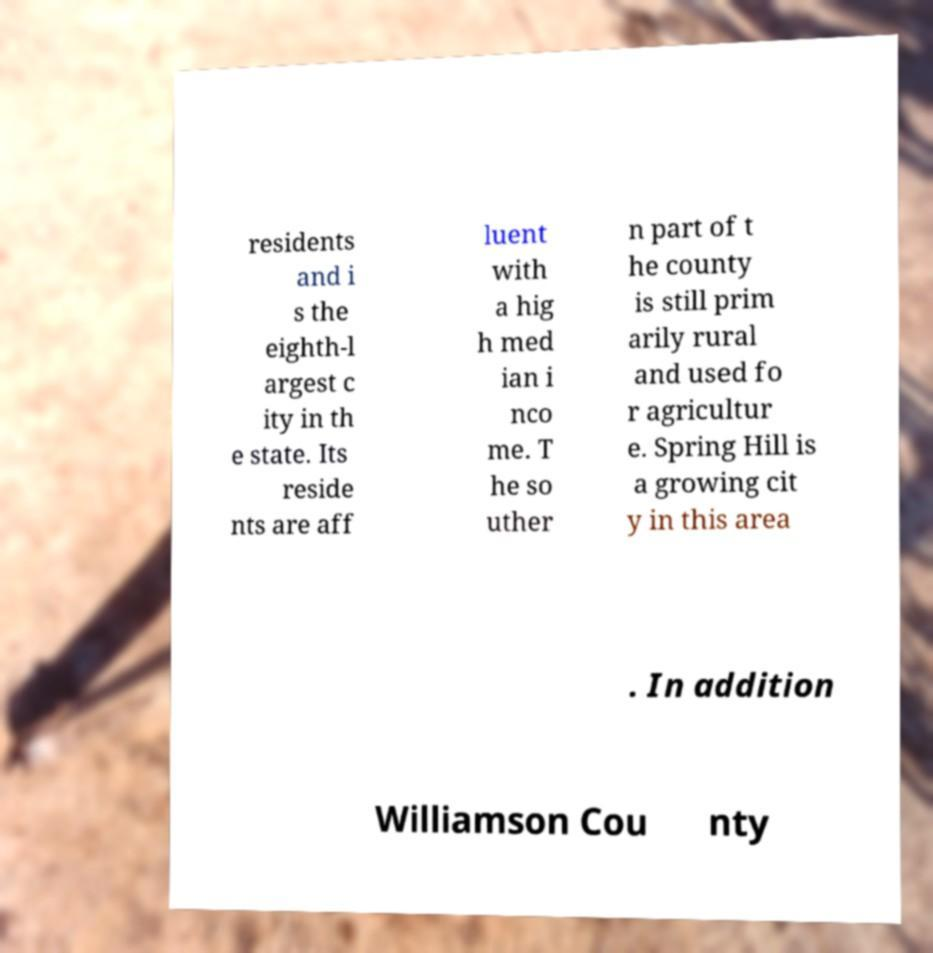Please identify and transcribe the text found in this image. residents and i s the eighth-l argest c ity in th e state. Its reside nts are aff luent with a hig h med ian i nco me. T he so uther n part of t he county is still prim arily rural and used fo r agricultur e. Spring Hill is a growing cit y in this area . In addition Williamson Cou nty 